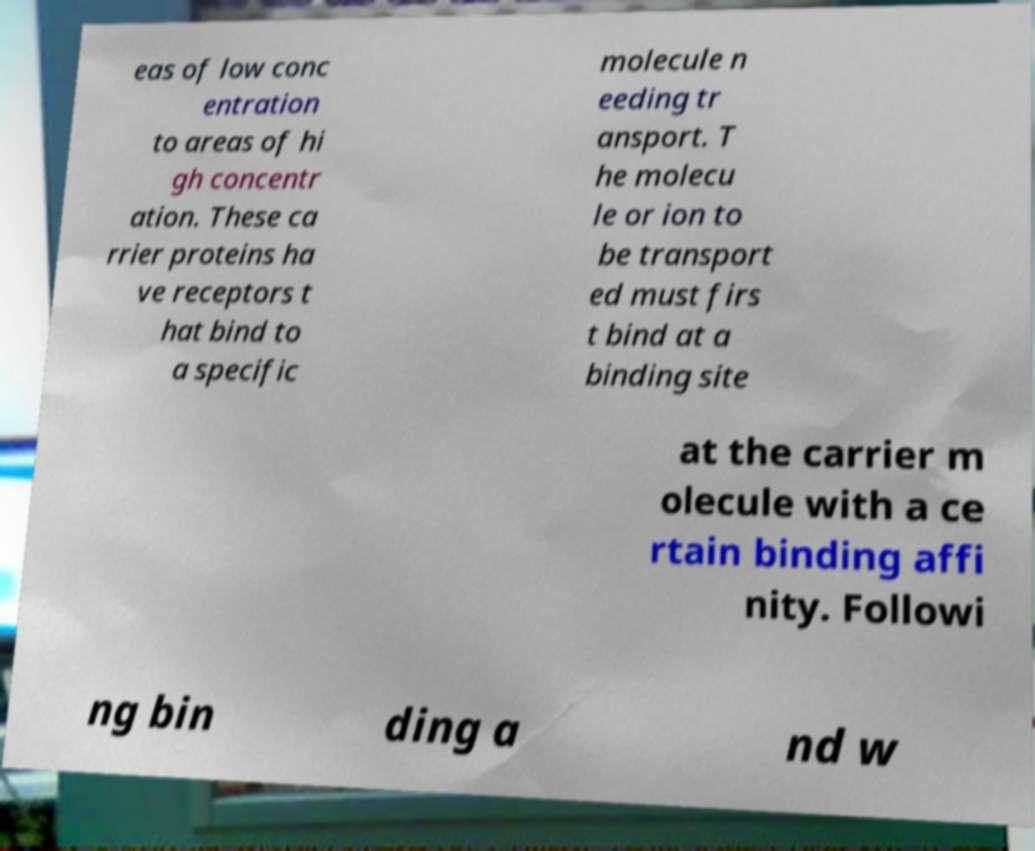For documentation purposes, I need the text within this image transcribed. Could you provide that? eas of low conc entration to areas of hi gh concentr ation. These ca rrier proteins ha ve receptors t hat bind to a specific molecule n eeding tr ansport. T he molecu le or ion to be transport ed must firs t bind at a binding site at the carrier m olecule with a ce rtain binding affi nity. Followi ng bin ding a nd w 